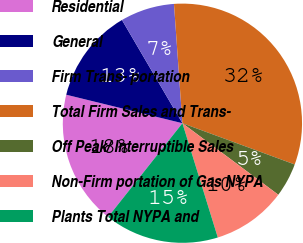<chart> <loc_0><loc_0><loc_500><loc_500><pie_chart><fcel>Residential<fcel>General<fcel>Firm Trans- portation<fcel>Total Firm Sales and Trans-<fcel>Off Peak/ Interruptible Sales<fcel>Non-Firm portation of Gas NYPA<fcel>Plants Total NYPA and<nl><fcel>18.16%<fcel>12.74%<fcel>7.31%<fcel>31.73%<fcel>4.6%<fcel>10.02%<fcel>15.45%<nl></chart> 